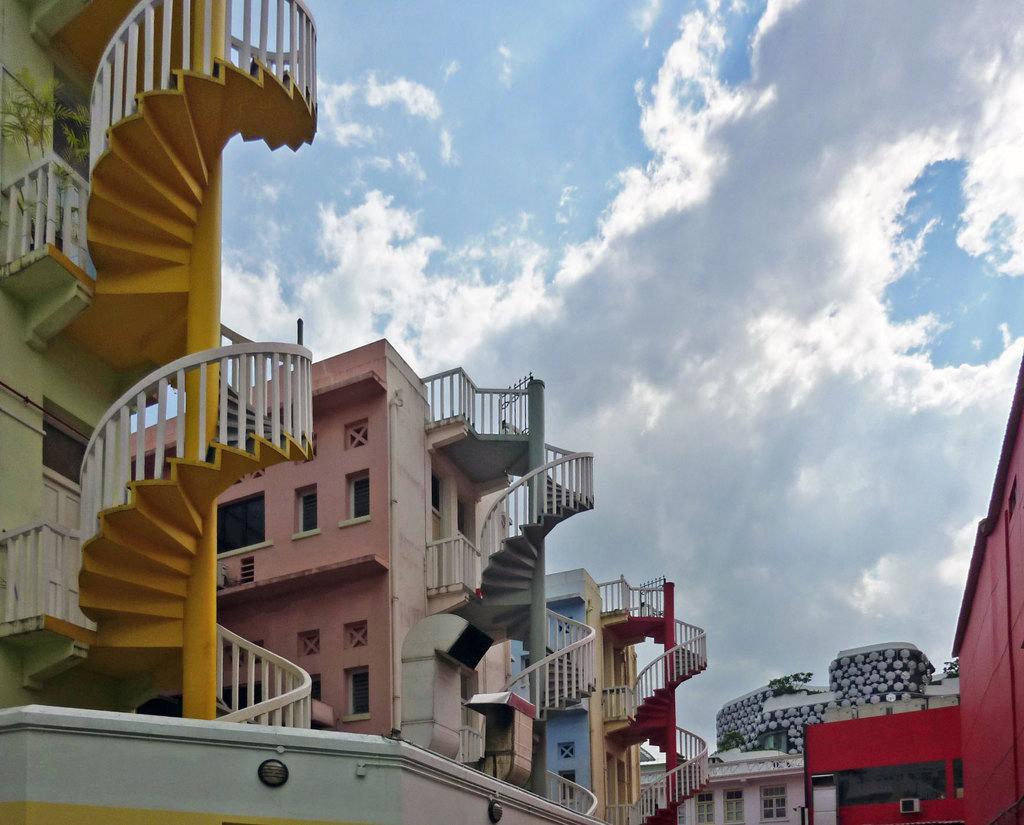Can you describe this image briefly? In this picture we can see many buildings. Here we can see concrete stairs and fencing. On the top we can see sky and clouds. 